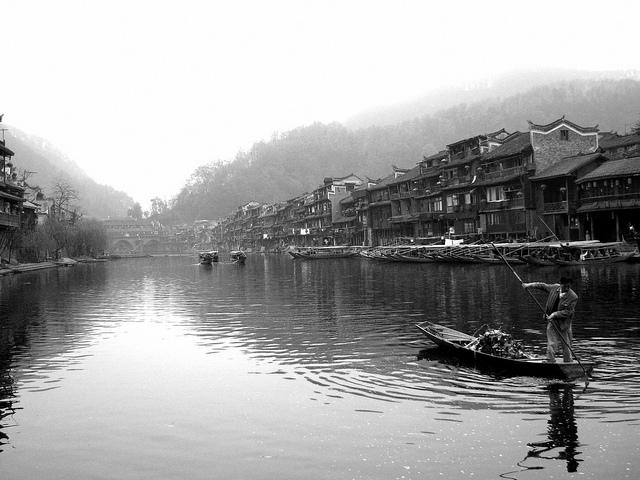Which type action propels the nearest boat forward? paddling 